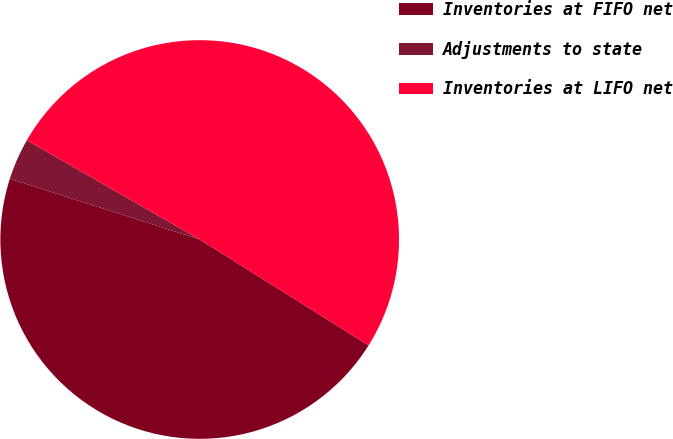<chart> <loc_0><loc_0><loc_500><loc_500><pie_chart><fcel>Inventories at FIFO net<fcel>Adjustments to state<fcel>Inventories at LIFO net<nl><fcel>46.02%<fcel>3.36%<fcel>50.62%<nl></chart> 